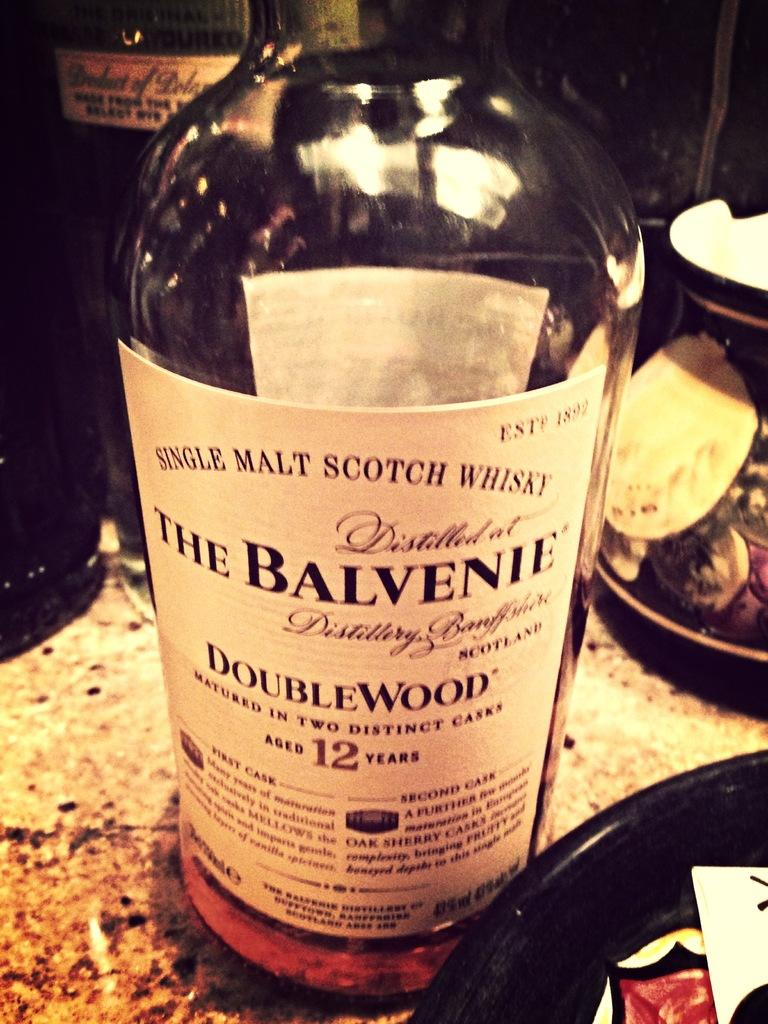What object can be seen in the image? There is a bottle in the image. What type of mine is depicted in the image? There is no mine present in the image; it only features a bottle. What is the name of the farm shown in the image? There is no farm present in the image; it only features a bottle. 